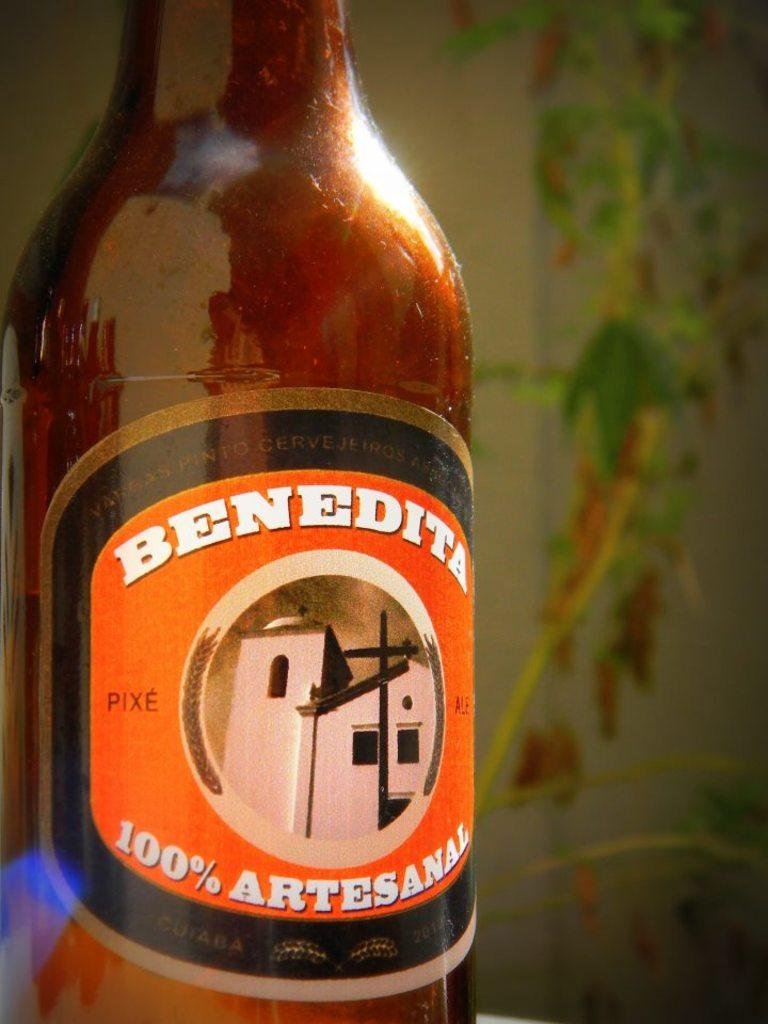<image>
Describe the image concisely. A tall brown glass bottle with an orange label that reads Benedita 100% artesanal 